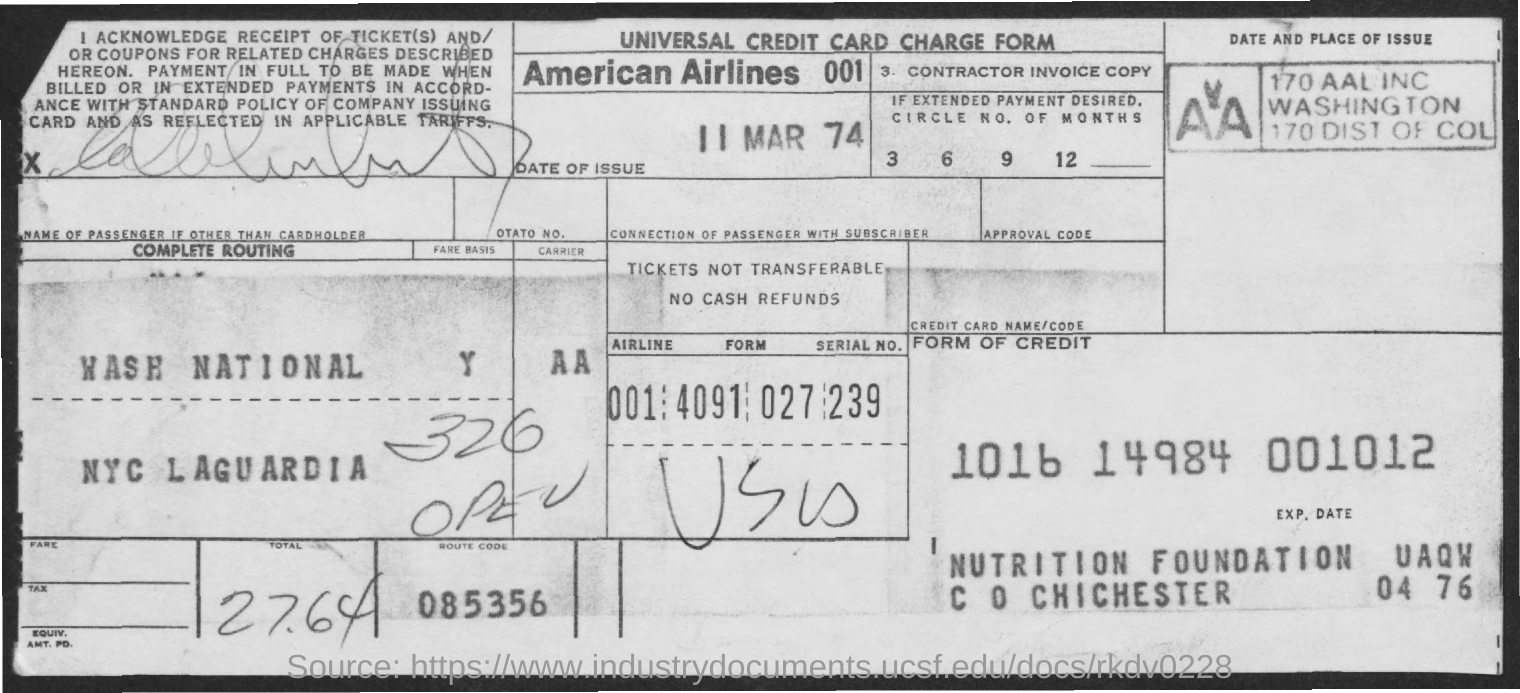What type of document is it?
Keep it short and to the point. Universal credit card charge form. What is the airlines name?
Keep it short and to the point. AMerican Airlines. What is the route code?
Your answer should be compact. 085356. What is the total amount?
Provide a succinct answer. 27.64. What is the date of issue?
Your response must be concise. 11 mar 74. 